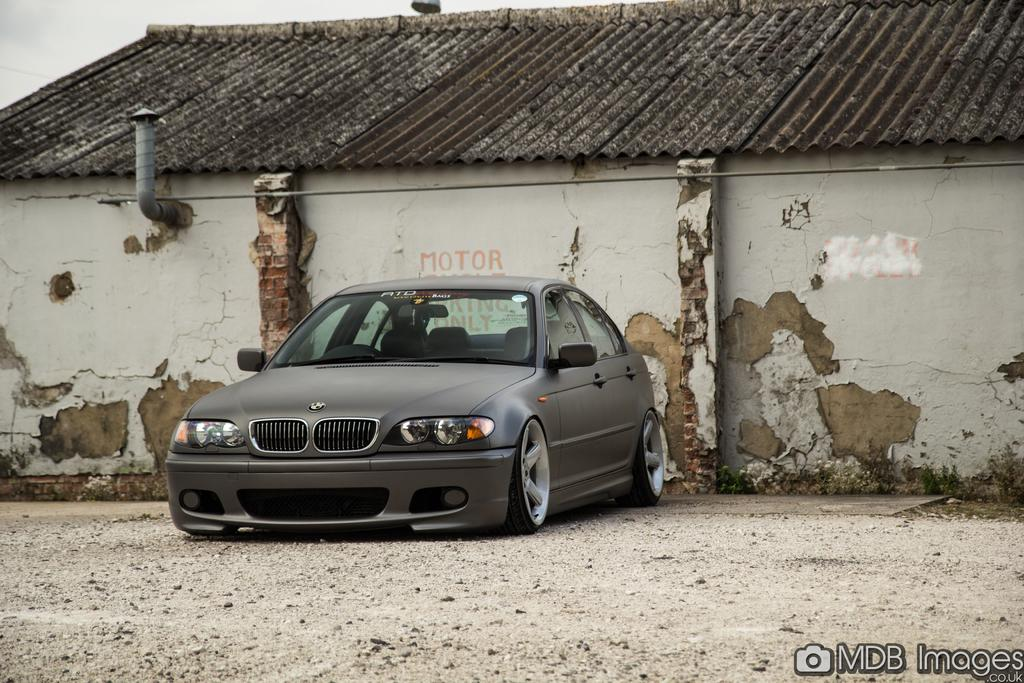What is the main subject of the image? There is a car in the image. What can be seen in the background of the image? There is a shed in the background of the image. What is visible above the car in the image? The sky is visible in the image. Is there any text or logo present in the image? Yes, there is a watermark in the bottom right-hand corner of the image. How many apples are on the bed in the image? There are no apples or beds present in the image. 